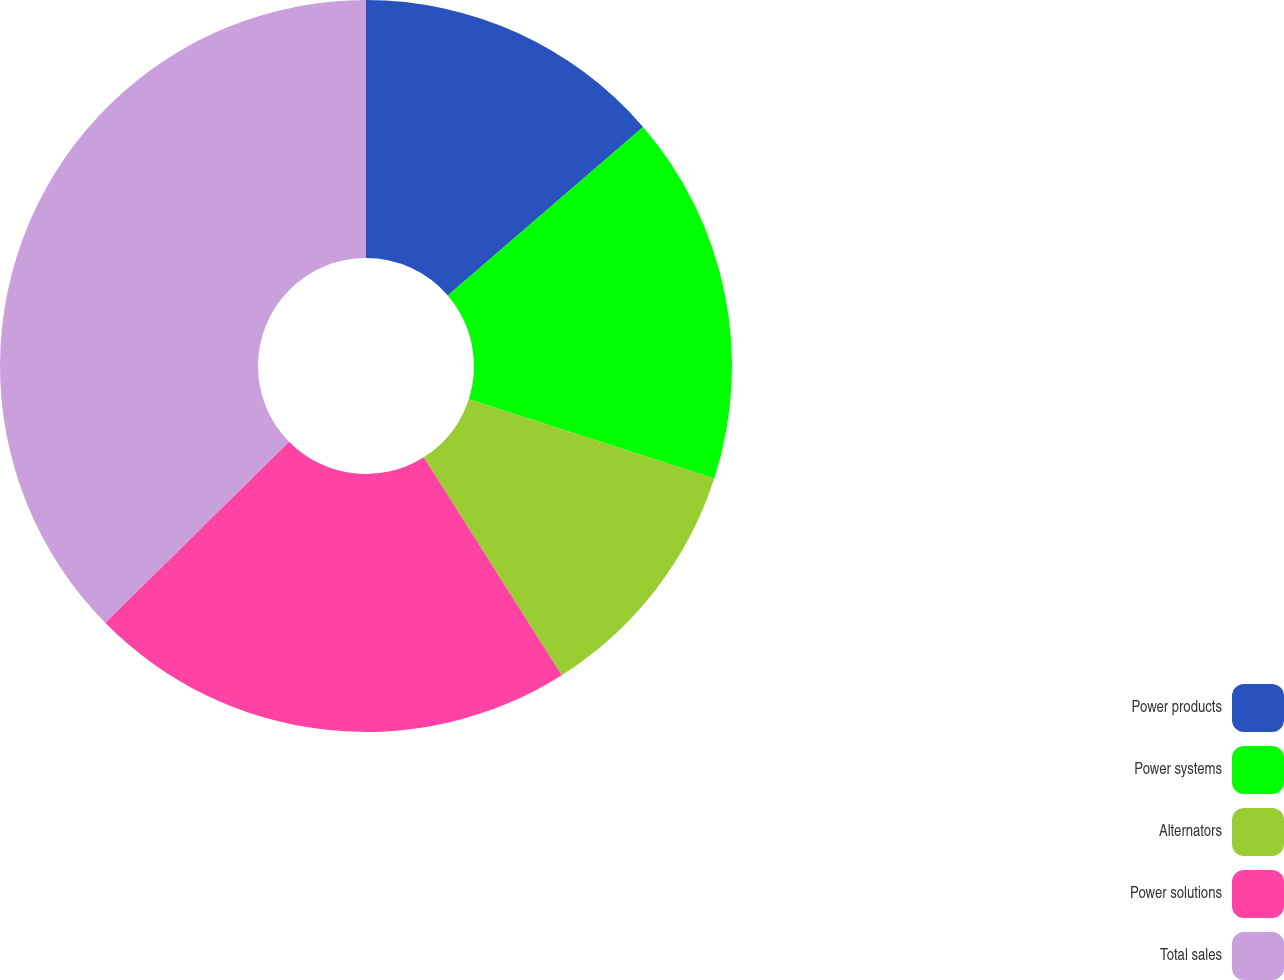<chart> <loc_0><loc_0><loc_500><loc_500><pie_chart><fcel>Power products<fcel>Power systems<fcel>Alternators<fcel>Power solutions<fcel>Total sales<nl><fcel>13.67%<fcel>16.31%<fcel>11.04%<fcel>21.61%<fcel>37.38%<nl></chart> 